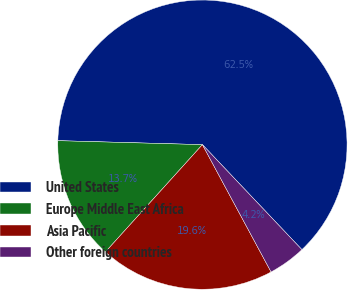Convert chart to OTSL. <chart><loc_0><loc_0><loc_500><loc_500><pie_chart><fcel>United States<fcel>Europe Middle East Africa<fcel>Asia Pacific<fcel>Other foreign countries<nl><fcel>62.49%<fcel>13.74%<fcel>19.57%<fcel>4.2%<nl></chart> 